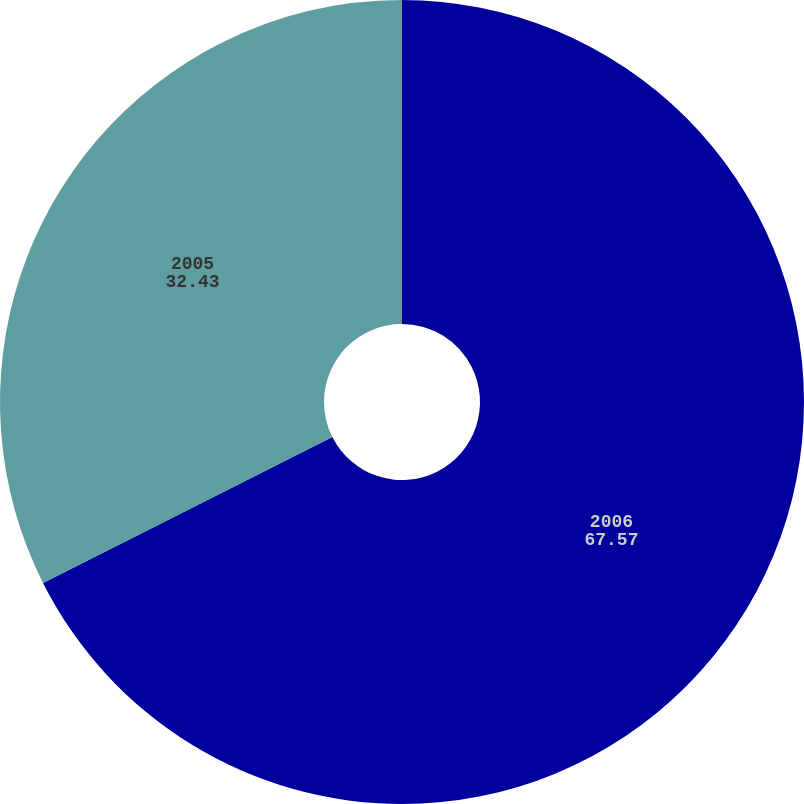Convert chart. <chart><loc_0><loc_0><loc_500><loc_500><pie_chart><fcel>2006<fcel>2005<nl><fcel>67.57%<fcel>32.43%<nl></chart> 